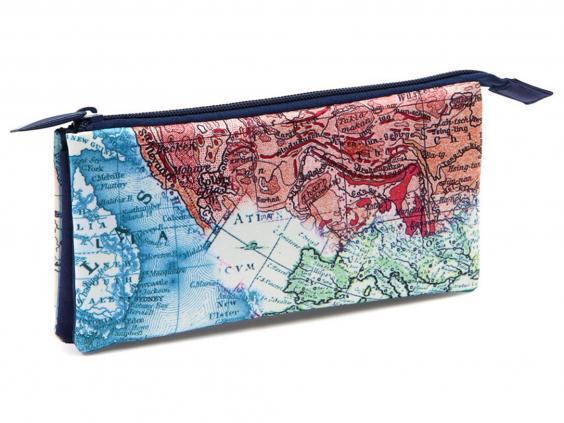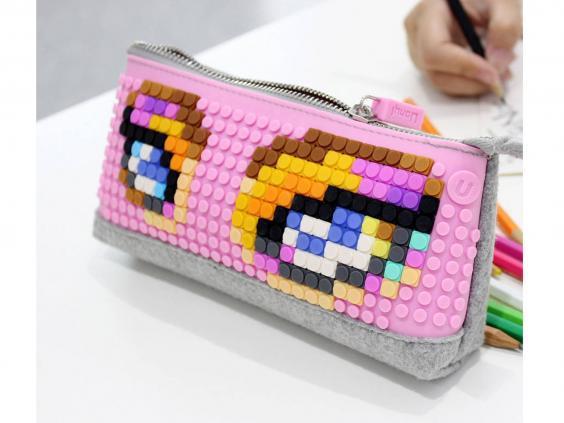The first image is the image on the left, the second image is the image on the right. Considering the images on both sides, is "There is a predominantly pink pencel case on top of a white table in one of the images." valid? Answer yes or no. Yes. 